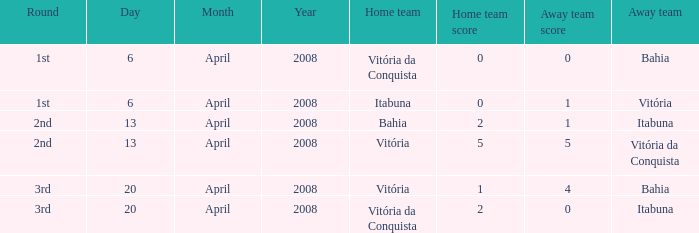Can you parse all the data within this table? {'header': ['Round', 'Day', 'Month', 'Year', 'Home team', 'Home team score', 'Away team score', 'Away team'], 'rows': [['1st', '6', 'April', '2008', 'Vitória da Conquista', '0', '0', 'Bahia'], ['1st', '6', 'April', '2008', 'Itabuna', '0', '1', 'Vitória'], ['2nd', '13', 'April', '2008', 'Bahia', '2', '1', 'Itabuna'], ['2nd', '13', 'April', '2008', 'Vitória', '5', '5', 'Vitória da Conquista'], ['3rd', '20', 'April', '2008', 'Vitória', '1', '4', 'Bahia'], ['3rd', '20', 'April', '2008', 'Vitória da Conquista', '2', '0', 'Itabuna']]} What home team has a score of 5 - 5? Vitória. 